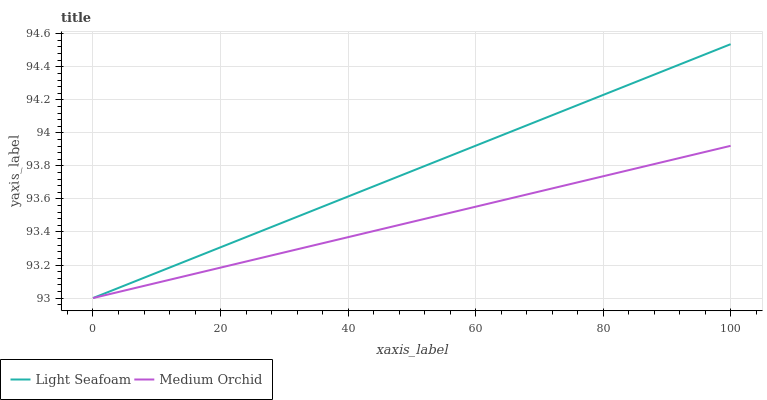Does Medium Orchid have the minimum area under the curve?
Answer yes or no. Yes. Does Light Seafoam have the maximum area under the curve?
Answer yes or no. Yes. Does Light Seafoam have the minimum area under the curve?
Answer yes or no. No. Is Medium Orchid the smoothest?
Answer yes or no. Yes. Is Light Seafoam the roughest?
Answer yes or no. Yes. Is Light Seafoam the smoothest?
Answer yes or no. No. Does Medium Orchid have the lowest value?
Answer yes or no. Yes. Does Light Seafoam have the highest value?
Answer yes or no. Yes. Does Medium Orchid intersect Light Seafoam?
Answer yes or no. Yes. Is Medium Orchid less than Light Seafoam?
Answer yes or no. No. Is Medium Orchid greater than Light Seafoam?
Answer yes or no. No. 